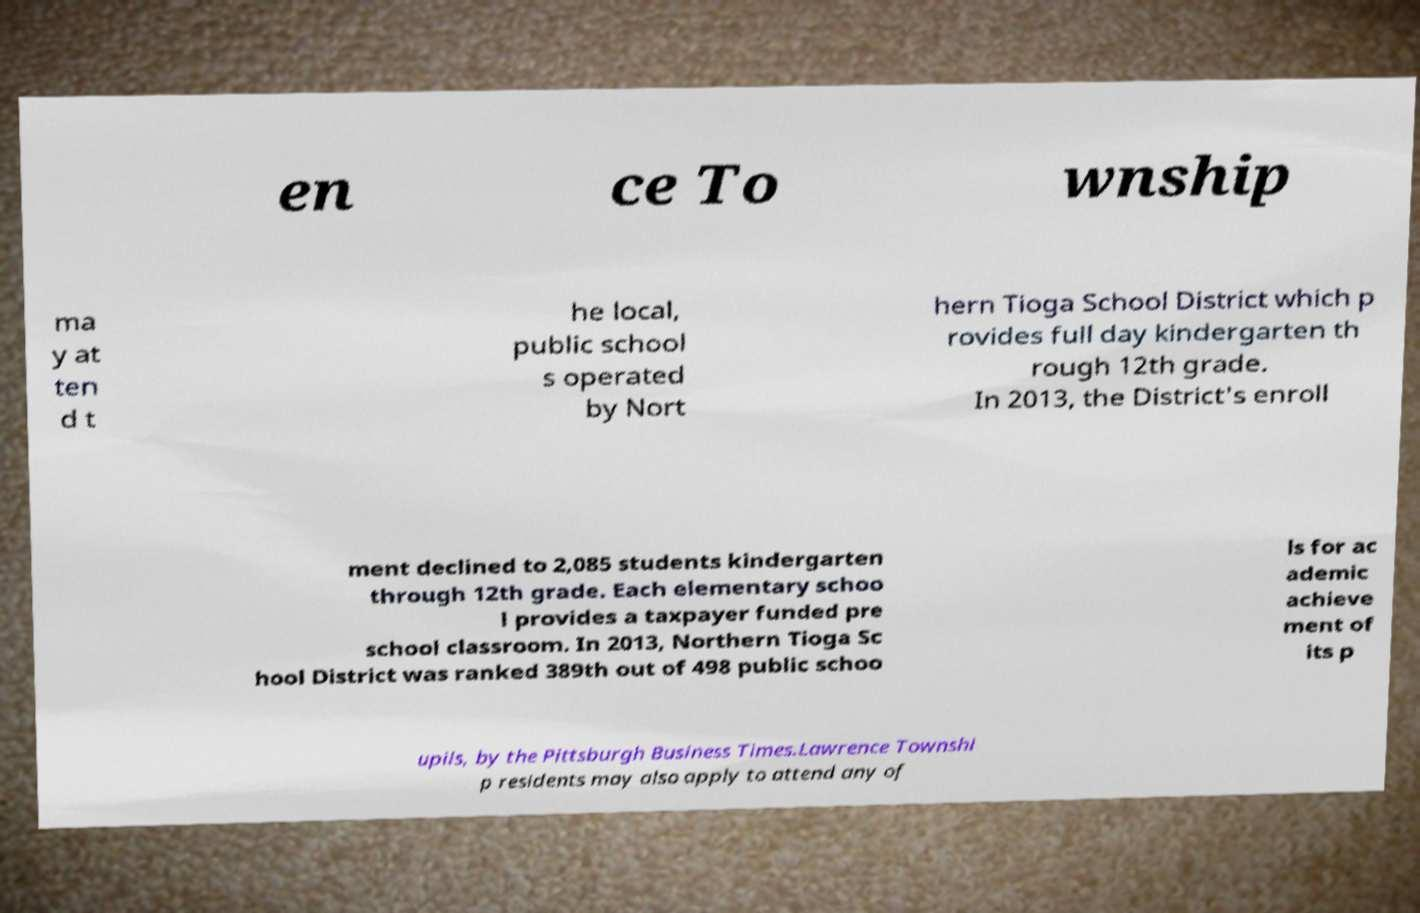For documentation purposes, I need the text within this image transcribed. Could you provide that? en ce To wnship ma y at ten d t he local, public school s operated by Nort hern Tioga School District which p rovides full day kindergarten th rough 12th grade. In 2013, the District's enroll ment declined to 2,085 students kindergarten through 12th grade. Each elementary schoo l provides a taxpayer funded pre school classroom. In 2013, Northern Tioga Sc hool District was ranked 389th out of 498 public schoo ls for ac ademic achieve ment of its p upils, by the Pittsburgh Business Times.Lawrence Townshi p residents may also apply to attend any of 